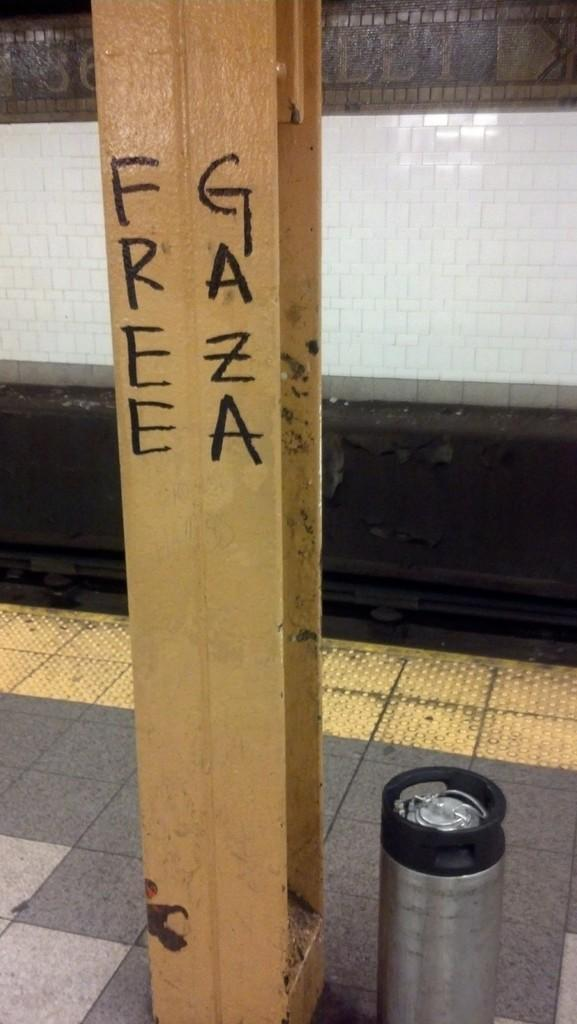<image>
Present a compact description of the photo's key features. A steel beam that has Free Gaza on it 